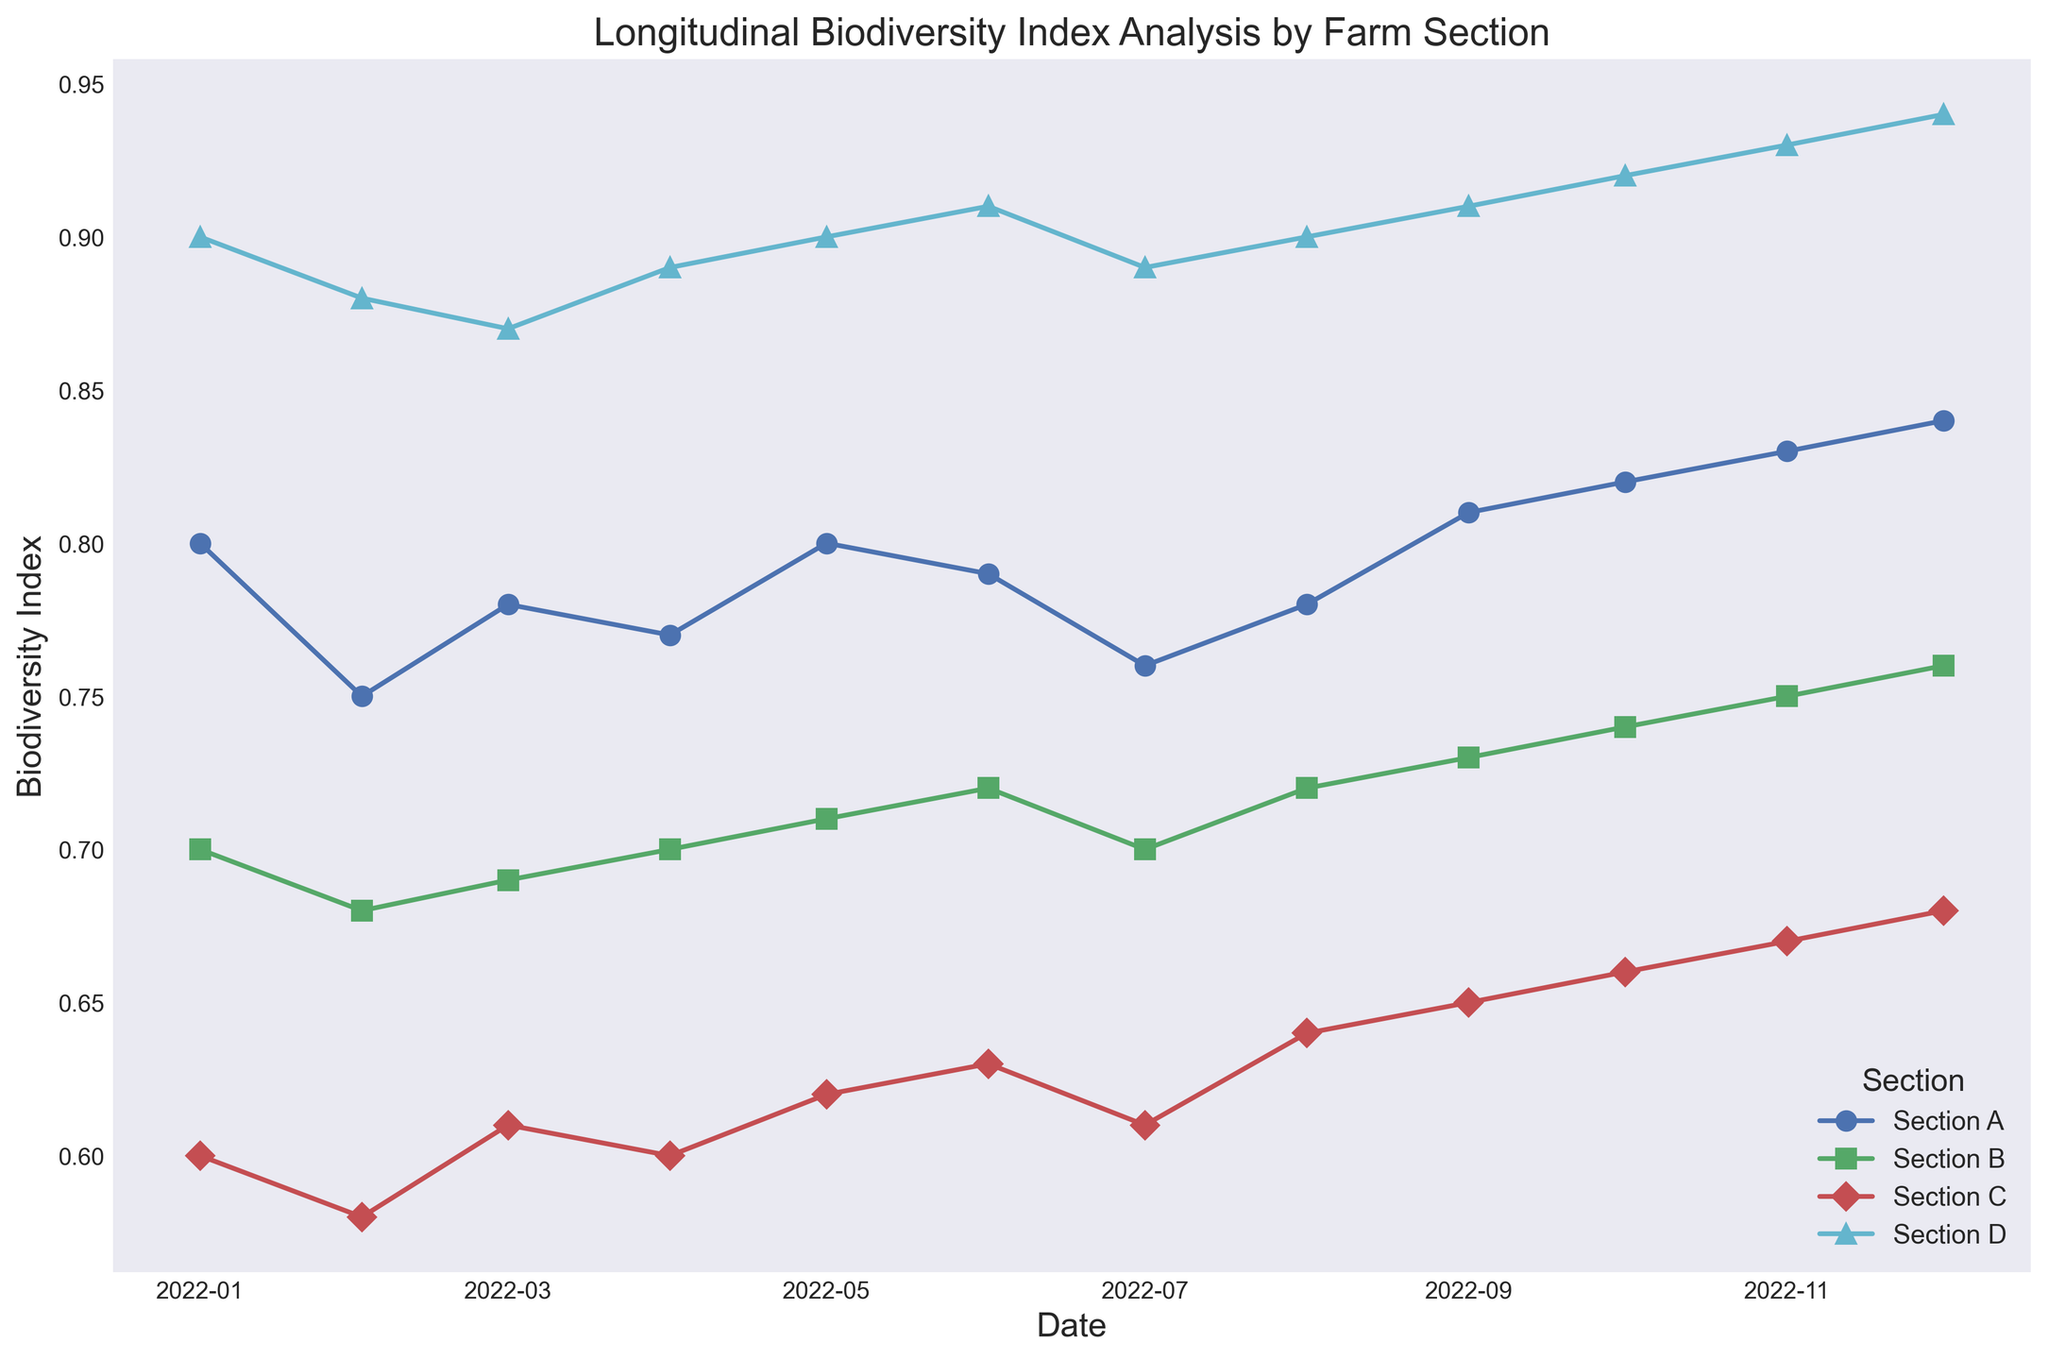Which section had the highest Biodiversity Index in December 2022? First, locate December 2022 on the x-axis. Then, identify the section with the highest y-value (Biodiversity Index) among all the lines.
Answer: Section D How did the Biodiversity Index of Section C change from January 2022 to December 2022? Locate January 2022 and December 2022 on the x-axis for Section C. Compare the Biodiversity Index at both points. The index increased from 0.6 to 0.68.
Answer: It increased Compare the Biodiversity Index of Section A and Section B in June 2022. Which one is higher? Locate June 2022 on the x-axis. Follow the y-values (Biodiversity Index) of Section A and Section B at this date. Section A has a higher index than Section B in this month.
Answer: Section A What was the average Biodiversity Index for Section D in 2022? Sum the Biodiversity Index values for each month in Section D and then divide by the number of months (12). The sum is 10.83, so the average is 10.83 / 12 ≈ 0.9025.
Answer: 0.9025 Which section showed the most significant improvement in Biodiversity Index over 2022? Compare the changes in Biodiversity Index from January to December 2022 for each section. Section D improved from 0.9 to 0.94, an increase of 0.04, which is the most significant improvement.
Answer: Section D In which month did Section B’s Biodiversity Index exceed 0.7 for the first time? Check the y-values of Section B starting from January 2022 and identify the first month where the index exceeds 0.7. This occurs in May 2022.
Answer: May 2022 By how much did the Biodiversity Index of Section A decrease in February 2022 compared to January 2022? Look at the Biodiversity Index of Section A in January (0.8) and February (0.75). The decrease is 0.8 - 0.75 = 0.05.
Answer: 0.05 Which section had the highest Biodiversity Index fluctuation throughout 2022? Evaluate the maximum and minimum Biodiversity Index for each section throughout 2022 and calculate the differences. Section D fluctuated by 0.94 - 0.87 = 0.07, the highest among all sections.
Answer: Section D 